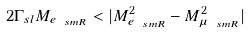<formula> <loc_0><loc_0><loc_500><loc_500>2 \Gamma _ { s l } M _ { e _ { \ s m R } } < | M ^ { 2 } _ { e _ { \ s m R } } - M ^ { 2 } _ { \mu _ { \ s m R } } |</formula> 